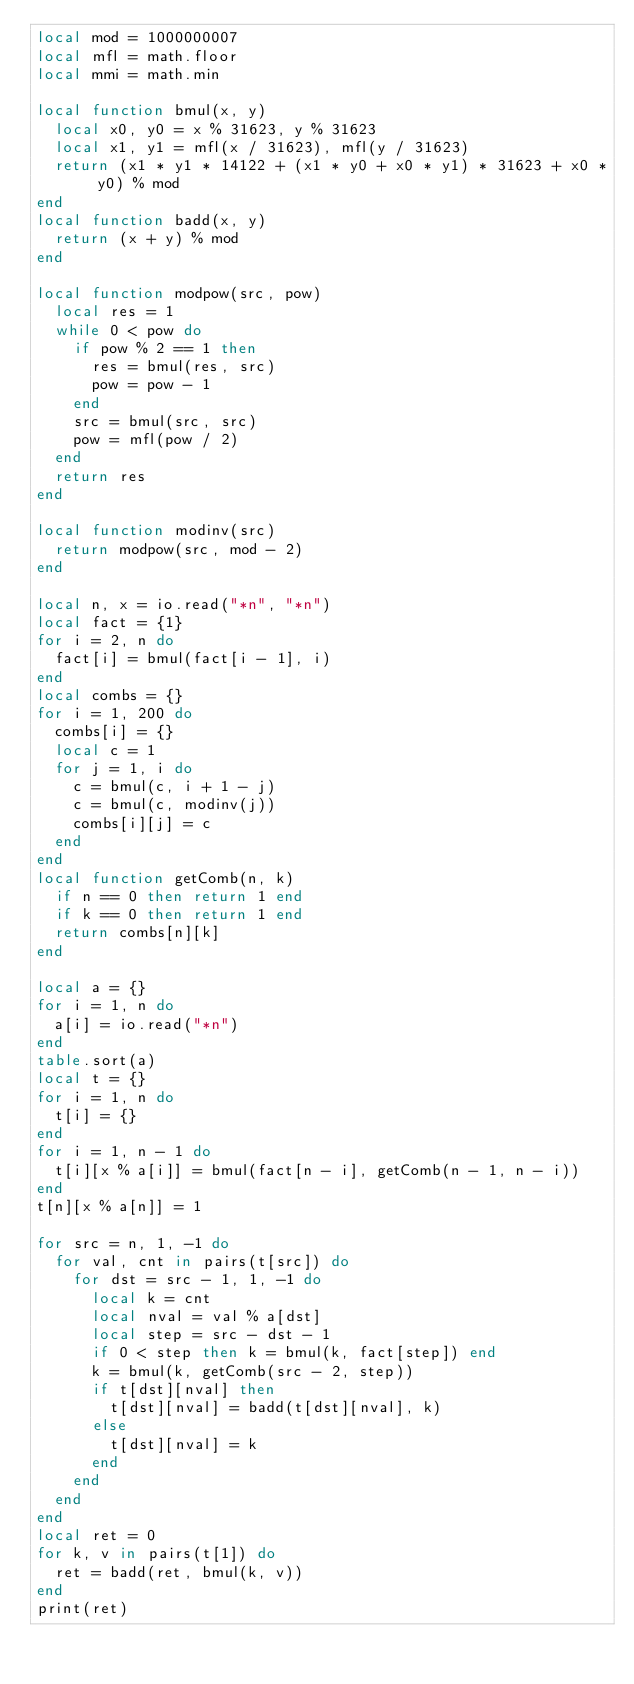<code> <loc_0><loc_0><loc_500><loc_500><_Lua_>local mod = 1000000007
local mfl = math.floor
local mmi = math.min

local function bmul(x, y)
  local x0, y0 = x % 31623, y % 31623
  local x1, y1 = mfl(x / 31623), mfl(y / 31623)
  return (x1 * y1 * 14122 + (x1 * y0 + x0 * y1) * 31623 + x0 * y0) % mod
end
local function badd(x, y)
  return (x + y) % mod
end

local function modpow(src, pow)
  local res = 1
  while 0 < pow do
    if pow % 2 == 1 then
      res = bmul(res, src)
      pow = pow - 1
    end
    src = bmul(src, src)
    pow = mfl(pow / 2)
  end
  return res
end

local function modinv(src)
  return modpow(src, mod - 2)
end

local n, x = io.read("*n", "*n")
local fact = {1}
for i = 2, n do
  fact[i] = bmul(fact[i - 1], i)
end
local combs = {}
for i = 1, 200 do
  combs[i] = {}
  local c = 1
  for j = 1, i do
    c = bmul(c, i + 1 - j)
    c = bmul(c, modinv(j))
    combs[i][j] = c
  end
end
local function getComb(n, k)
  if n == 0 then return 1 end
  if k == 0 then return 1 end
  return combs[n][k]
end

local a = {}
for i = 1, n do
  a[i] = io.read("*n")
end
table.sort(a)
local t = {}
for i = 1, n do
  t[i] = {}
end
for i = 1, n - 1 do
  t[i][x % a[i]] = bmul(fact[n - i], getComb(n - 1, n - i))
end
t[n][x % a[n]] = 1

for src = n, 1, -1 do
  for val, cnt in pairs(t[src]) do
    for dst = src - 1, 1, -1 do
      local k = cnt
      local nval = val % a[dst]
      local step = src - dst - 1
      if 0 < step then k = bmul(k, fact[step]) end
      k = bmul(k, getComb(src - 2, step))
      if t[dst][nval] then
        t[dst][nval] = badd(t[dst][nval], k)
      else
        t[dst][nval] = k
      end
    end
  end
end
local ret = 0
for k, v in pairs(t[1]) do
  ret = badd(ret, bmul(k, v))
end
print(ret)
</code> 